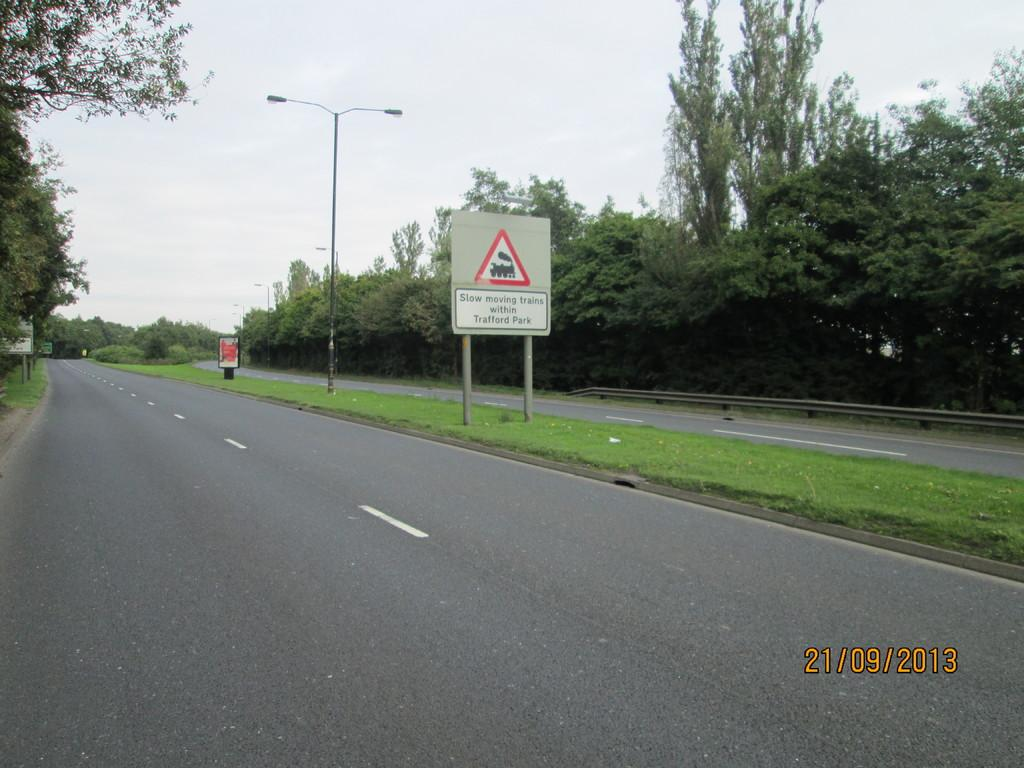<image>
Describe the image concisely. A sign that says slow moving trains and a date in 2013. 